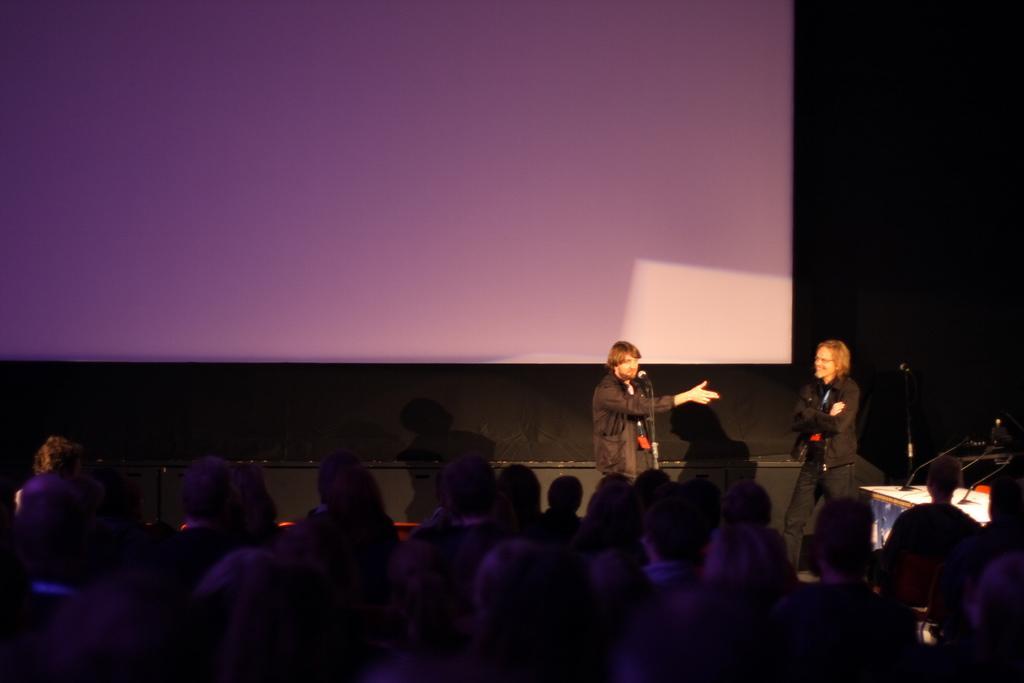Describe this image in one or two sentences. In this image I can see the group of people. In-front few tehse peopel i can see two people standing and there is a perosn in-front of teh mic. to the right I can see the mics on the table. in the background i can see the screen and there is a black background. 